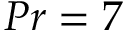Convert formula to latex. <formula><loc_0><loc_0><loc_500><loc_500>P r = 7</formula> 